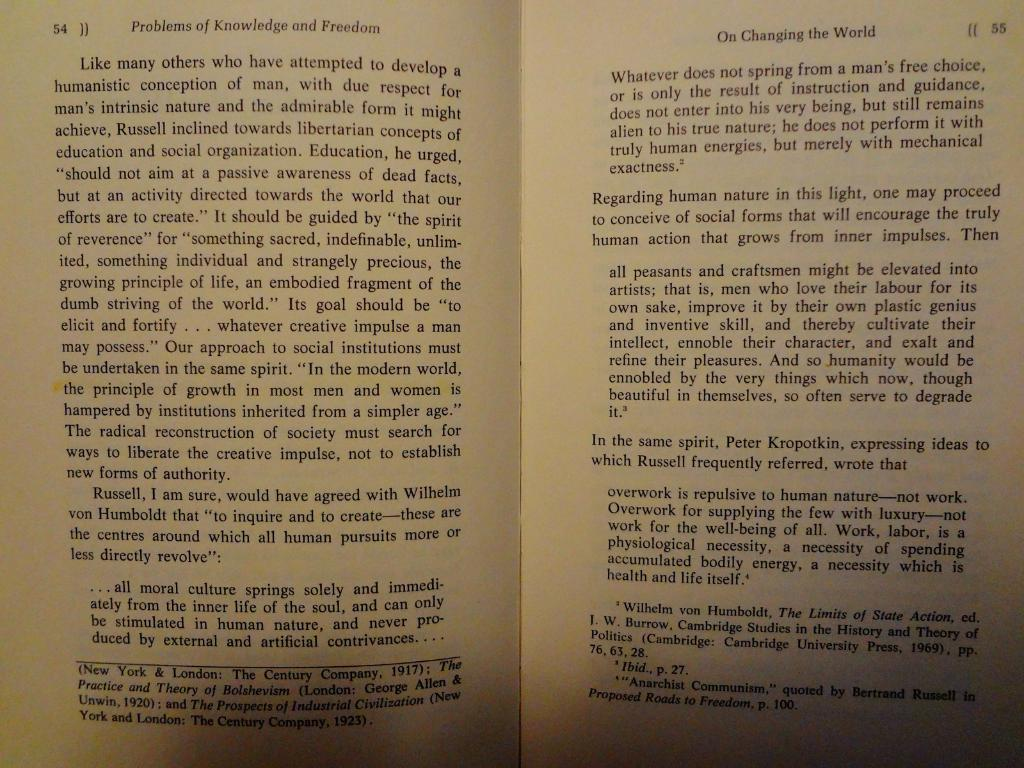<image>
Offer a succinct explanation of the picture presented. On open book on the subject of morals and freedom. 